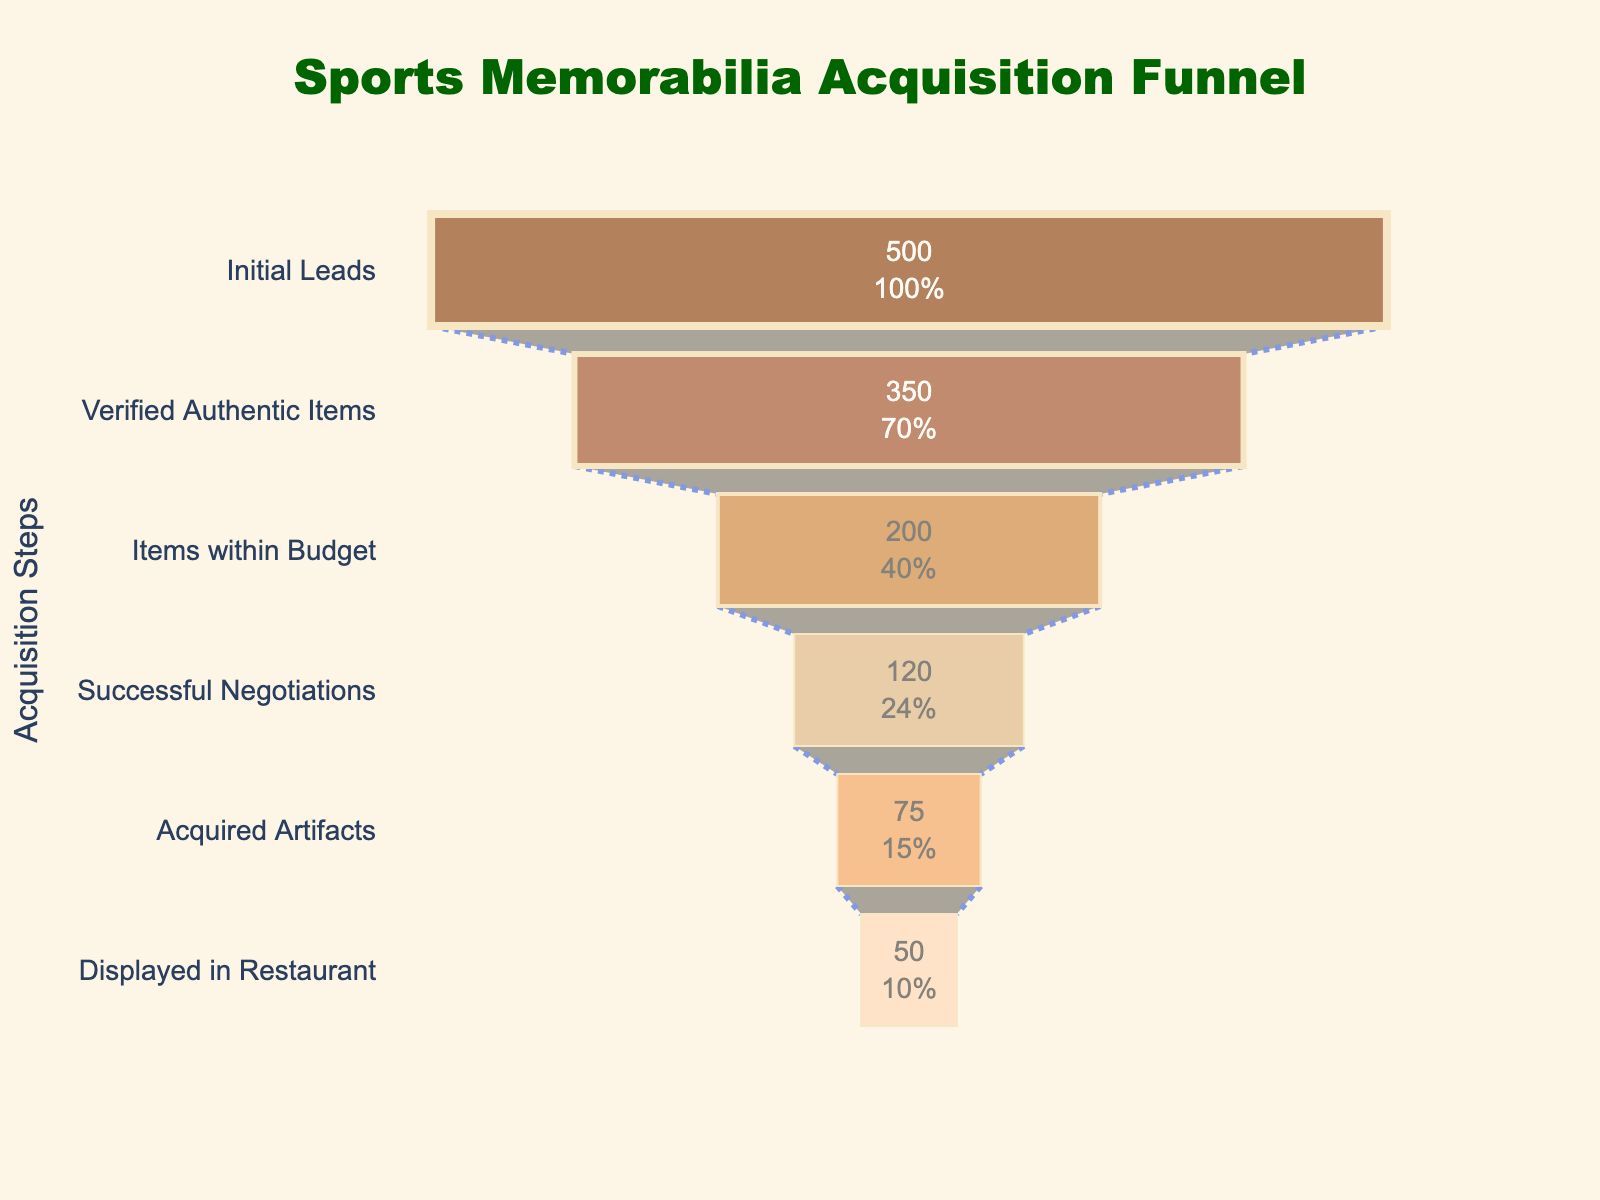What is the title of the funnel chart? The title of the funnel chart is displayed prominently at the top center of the chart in a larger and different color font. It reads "Sports Memorabilia Acquisition Funnel".
Answer: Sports Memorabilia Acquisition Funnel How many items are verified as authentic? The second step in the funnel chart, labeled "Verified Authentic Items," shows the number directly inside the funnel bar which indicates 350 verified authentic items.
Answer: 350 Which step has the fewest number of items? By comparing the values shown inside each funnel bar, the step "Displayed in Restaurant" has the fewest items with a total of 50.
Answer: Displayed in Restaurant What percentage of initial leads become acquired artifacts? The number of initial leads is 500, and the number of acquired artifacts is 75. To find the percentage: (75 / 500) * 100 = 15%.
Answer: 15% How many items are lost between 'Items within Budget' and 'Successful Negotiations'? The funnel chart shows 200 items within budget and 120 from successful negotiations. The difference is 200 - 120 = 80 items lost.
Answer: 80 What is the drop-off rate from 'Successful Negotiations' to 'Acquired Artifacts'? There are 120 successful negotiations and 75 acquired artifacts. The drop-off in number is 120 - 75 = 45 items. The drop-off rate is (45 / 120) * 100 = 37.5%.
Answer: 37.5% Which is greater: the number of 'Verified Authentic Items' or 'Items within Budget'? By comparing the values, 350 (Verified Authentic Items) is greater than 200 (Items within Budget).
Answer: Verified Authentic Items What proportion of acquired artifacts are displayed in the restaurant? There are 75 acquired artifacts and 50 displayed in the restaurant. The proportion is 50 / 75 = 0.6667, or approximately 66.67%.
Answer: 66.67% What color represents 'Initial Leads'? The funnel chart uses shades of brown for different steps. The first step, "Initial Leads," is colored in a dark brown shade.
Answer: Dark brown How many steps are in the funnel chart? By counting the labels on the y-axis of the funnel chart, there are a total of 6 steps shown.
Answer: 6 